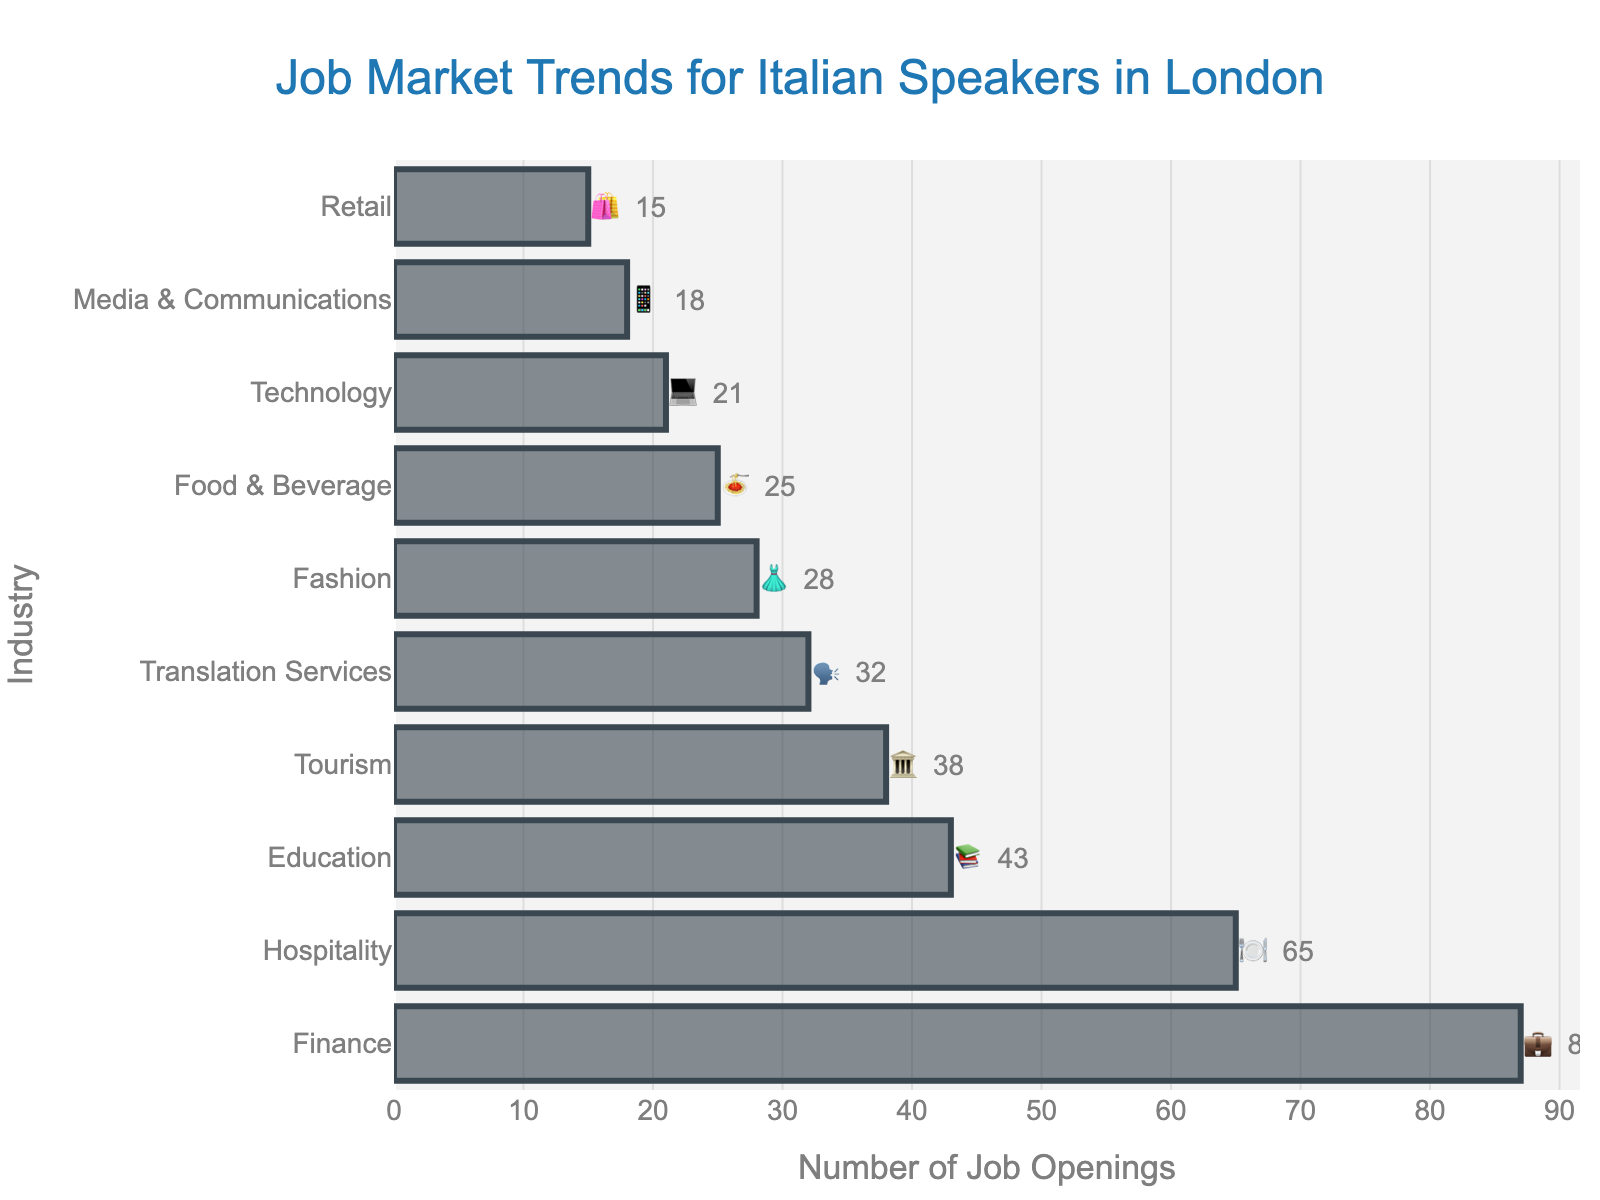What industry has the most job openings for Italian speakers in London? The industry with the highest bar value in the plot represents the category with the most job openings. Based on the chart, Finance has the tallest bar.
Answer: Finance What is the total number of job openings in the Fashion and Technology industries? Sum the job openings for both Fashion and Technology industries. Fashion has 28 openings and Technology has 21 openings. So, 28 + 21 = 49.
Answer: 49 Which industry has fewer job openings: Hospitality or Education? Compare the lengths of the bars for Hospitality and Education. Hospitality has 65 job openings, and Education has 43 job openings. Education has fewer job openings.
Answer: Education How many more job openings are there in Finance compared to Retail? Subtract the job openings in Retail from those in Finance. Finance has 87 openings and Retail has 15. So, 87 - 15 = 72.
Answer: 72 What is the average number of job openings across all industries? Add up all the job openings, then divide by the number of industries. The total job openings is 87 + 65 + 43 + 38 + 32 + 28 + 25 + 21 + 18 + 15 = 372. There are 10 industries, so the average is 372/10 = 37.2.
Answer: 37.2 Which industry has more job openings: Tourism or Translation Services? Compare the lengths of the bars for Tourism and Translation Services. Tourism has 38 job openings, while Translation Services has 32. Tourism has more job openings.
Answer: Tourism What is the combined percentage of job openings in Hospitality and Education compared to total job openings? Add job openings from Hospitality and Education, then divide by the total number of job openings, and multiply by 100 for the percentage. Total job openings are 372. Hospitality has 65 and Education has 43, so 65 + 43 = 108. The percentage is (108/372) * 100 ≈ 29.03%.
Answer: 29.03% What emoji represents the industry with the least number of job openings? Identify the industry with the smallest bar, which is Retail with 15 job openings, represented by the emoji 🛍️.
Answer: 🛍️ List the industries with fewer than 30 job openings along with their job openings numbers and emojis. Look at the bars that fall below 30 on the x-axis. The industries are Fashion (28, 👗), Food & Beverage (25, 🍝), Technology (21, 💻), Media & Communications (18, 📱), and Retail (15, 🛍️).
Answer: Fashion (28, 👗), Food & Beverage (25, 🍝), Technology (21, 💻), Media & Communications (18, 📱), Retail (15, 🛍️) What percentage of the total job openings does the Finance industry represent? Divide the job openings in Finance by the total number of job openings and multiply by 100. Finance has 87 job openings, and the total is 372, so the calculation is (87/372) * 100 ≈ 23.39%.
Answer: 23.39% 